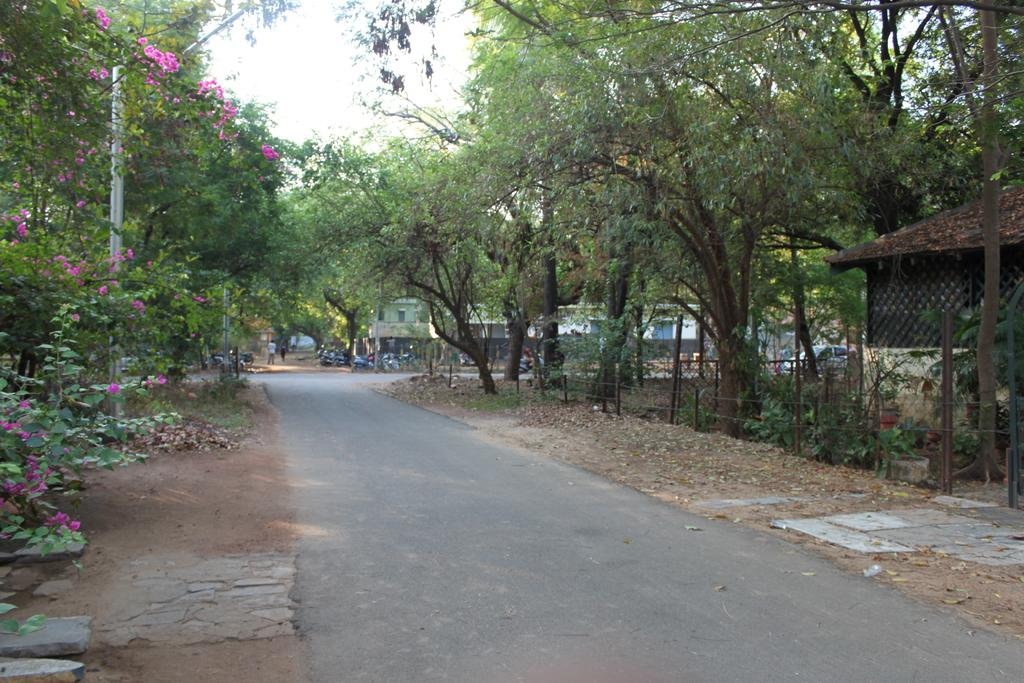What type of plants can be seen in the image? There are plants with flowers in the image. What type of barrier is present in the image? There is an iron fence in the image. What type of vegetation is visible in the image? There is grass in the image. What type of structures can be seen in the image? There are buildings in the image. What type of surface is visible in the image? There is a road in the image. What type of vehicles are present in the image? There are vehicles in the image. How many people are visible in the image? There are two people in the image. What type of natural features can be seen in the image? There are trees in the image. What part of the natural environment is visible in the image? The sky is visible in the image. What type of unit is being transported by the vessel in the image? There is no vessel or unit present in the image. How many bikes are visible in the image? There are no bikes visible in the image. 